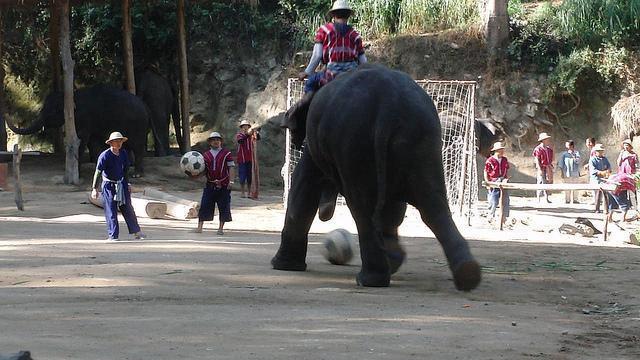How many people are there?
Give a very brief answer. 10. How many elephants have riders on them?
Give a very brief answer. 1. How many people are in the photo?
Give a very brief answer. 3. How many elephants are in the picture?
Give a very brief answer. 2. How many giraffes are inside the building?
Give a very brief answer. 0. 